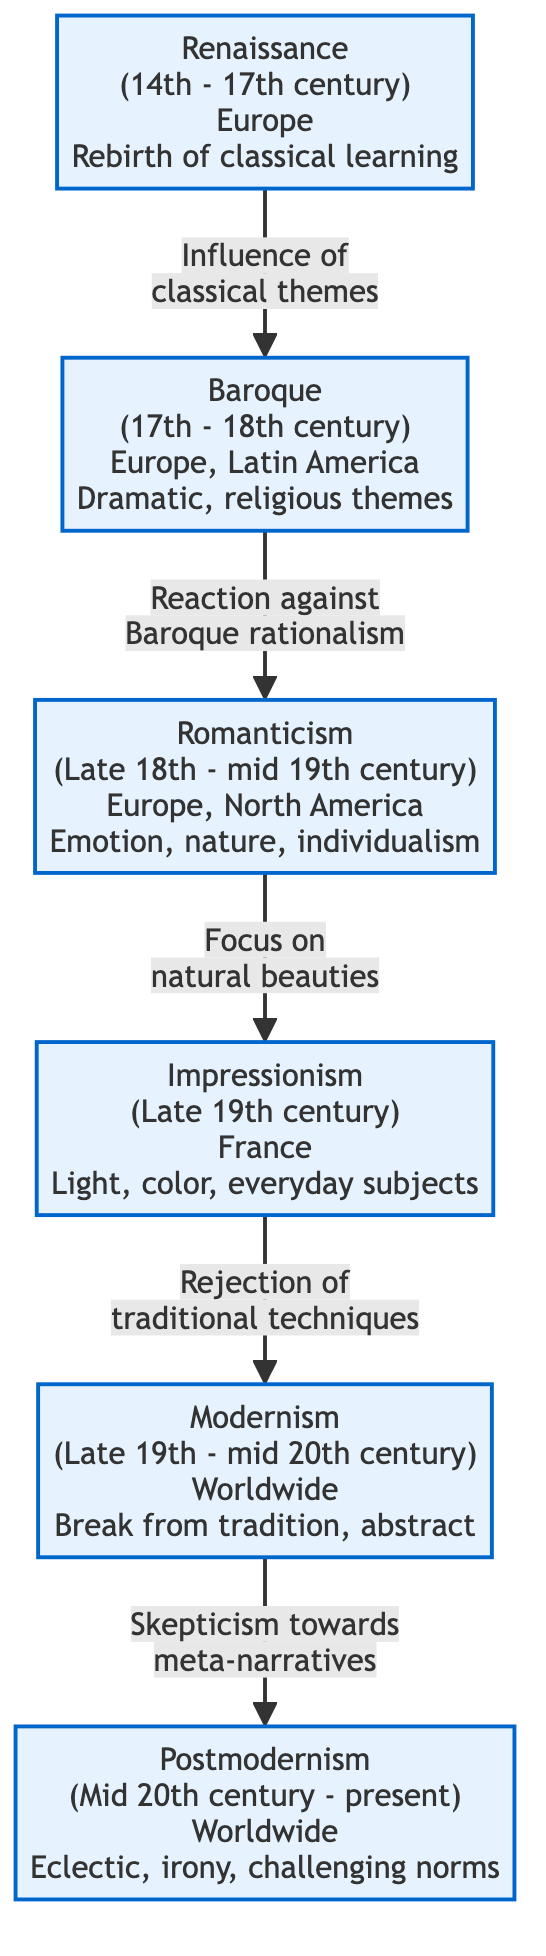What is the time period of the Renaissance? The Renaissance period spans from the 14th to the 17th century, as indicated in the diagram next to the Renaissance node.
Answer: 14th - 17th century How many artistic styles are represented in the diagram? There are 6 distinct artistic styles shown in the diagram: Renaissance, Baroque, Romanticism, Impressionism, Modernism, and Postmodernism.
Answer: 6 What type of themes does the Baroque style emphasize? The diagram describes Baroque themes as "Dramatic, religious themes," which is summarized within the Baroque node in the diagram.
Answer: Dramatic, religious themes Which artistic style follows Romanticism in the diagram? According to the diagram, Impressionism directly follows Romanticism, as shown by the arrow leading from Romanticism to Impressionism.
Answer: Impressionism What is the core focus of Impressionism? The diagram's node for Impressionism states that it focuses on "Light, color, everyday subjects," which summarizes the main aspects of that style.
Answer: Light, color, everyday subjects How does Modernism relate to Postmodernism? The connection is outlined in the diagram, indicating that Modernism reflects "Skepticism towards meta-narratives," leading to Postmodernism. This reveals the thematic development from Modernism to Postmodernism.
Answer: Skepticism towards meta-narratives What cultural influence is seen in the Renaissance? The diagram notes that the Renaissance was influenced by "classical themes," highlighting its connection to earlier periods and cultures.
Answer: Classical themes Which style depicts a reaction against Baroque rationalism? The diagram indicates that Romanticism is a reaction against Baroque rationalism, as shown by the arrow pointing from Baroque to Romanticism.
Answer: Romanticism What defines the emergence of Modernism based on the diagram? The diagram states that Modernism emerged as a "Break from tradition, abstract," indicating its foundational characteristics and context in art history.
Answer: Break from tradition, abstract 